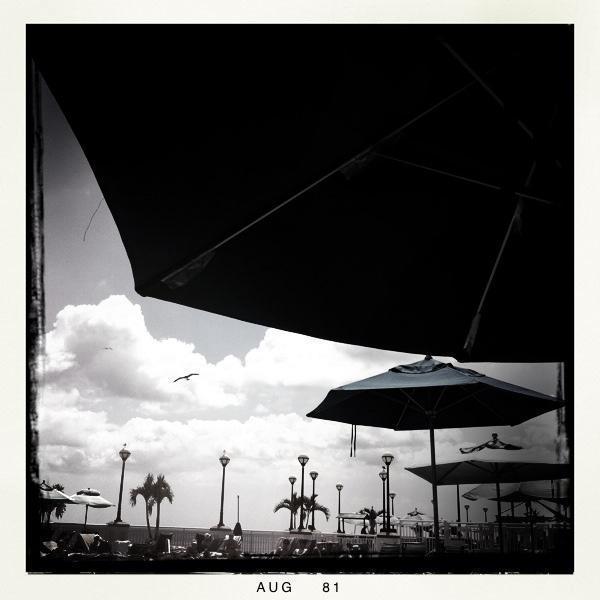How many birds do you see in the air?
Give a very brief answer. 1. How many umbrellas can you see?
Give a very brief answer. 3. How many giraffes can you see in the picture?
Give a very brief answer. 0. 